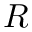<formula> <loc_0><loc_0><loc_500><loc_500>R</formula> 